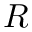<formula> <loc_0><loc_0><loc_500><loc_500>R</formula> 